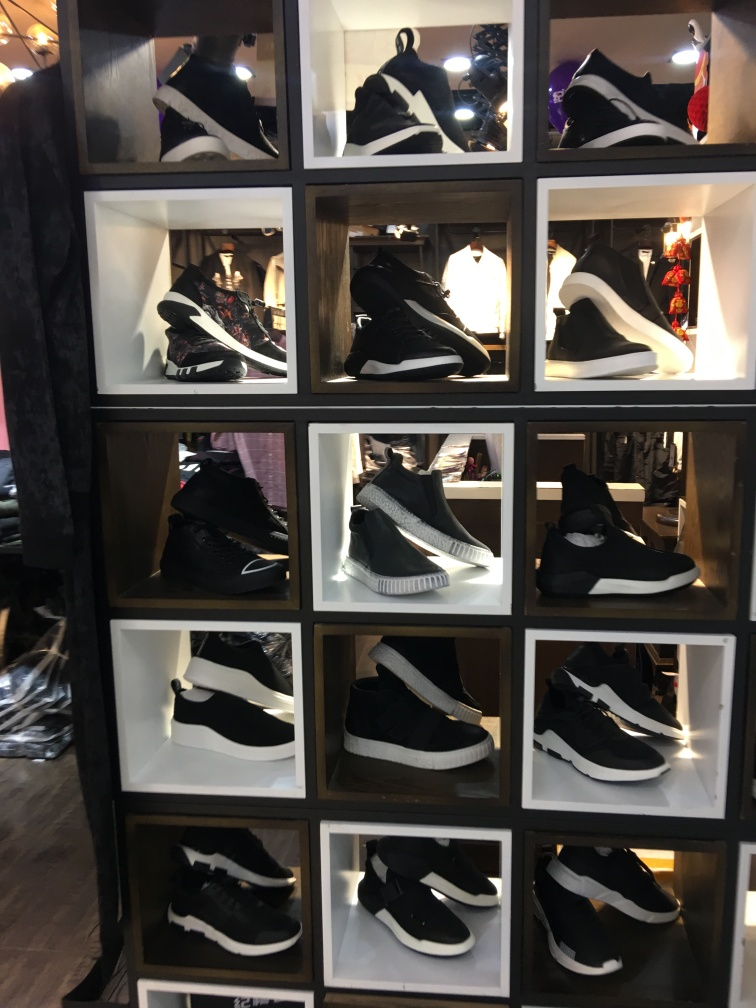Which pair of sneakers seems to have the most unique design? The sneakers displayed in the top-middle compartment have a distinctive high-top design with what appears to be a sock-like upper. This pair stands out due to its silhouette and seems to have a unique, fashionable aesthetic that differentiates it from the more traditional designs seen in the other compartments. 